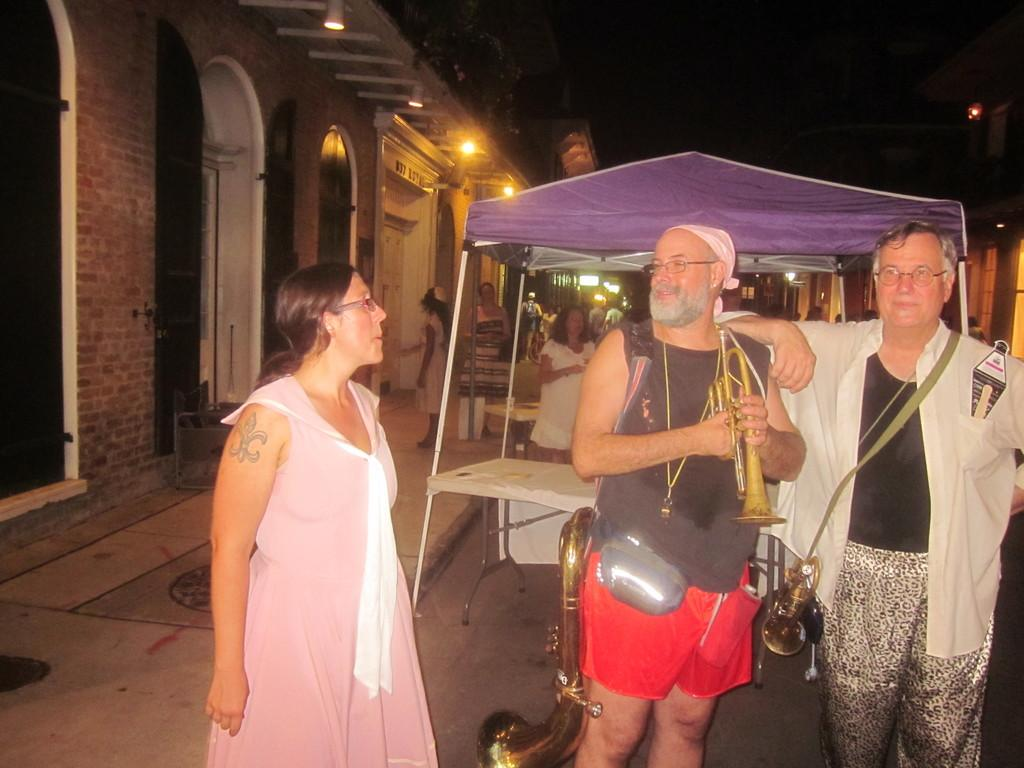What are the people in the foreground of the image doing? The people in the foreground of the image are holding musical instruments. How many people can be seen in the image? There are people in the image. What is present in the image besides the people? There is a stall in the image. What can be seen in the background of the image? There appears to be a building structure and light visible in the background. What type of mint is being used to flavor the oatmeal in the image? There is no oatmeal or mint present in the image. 